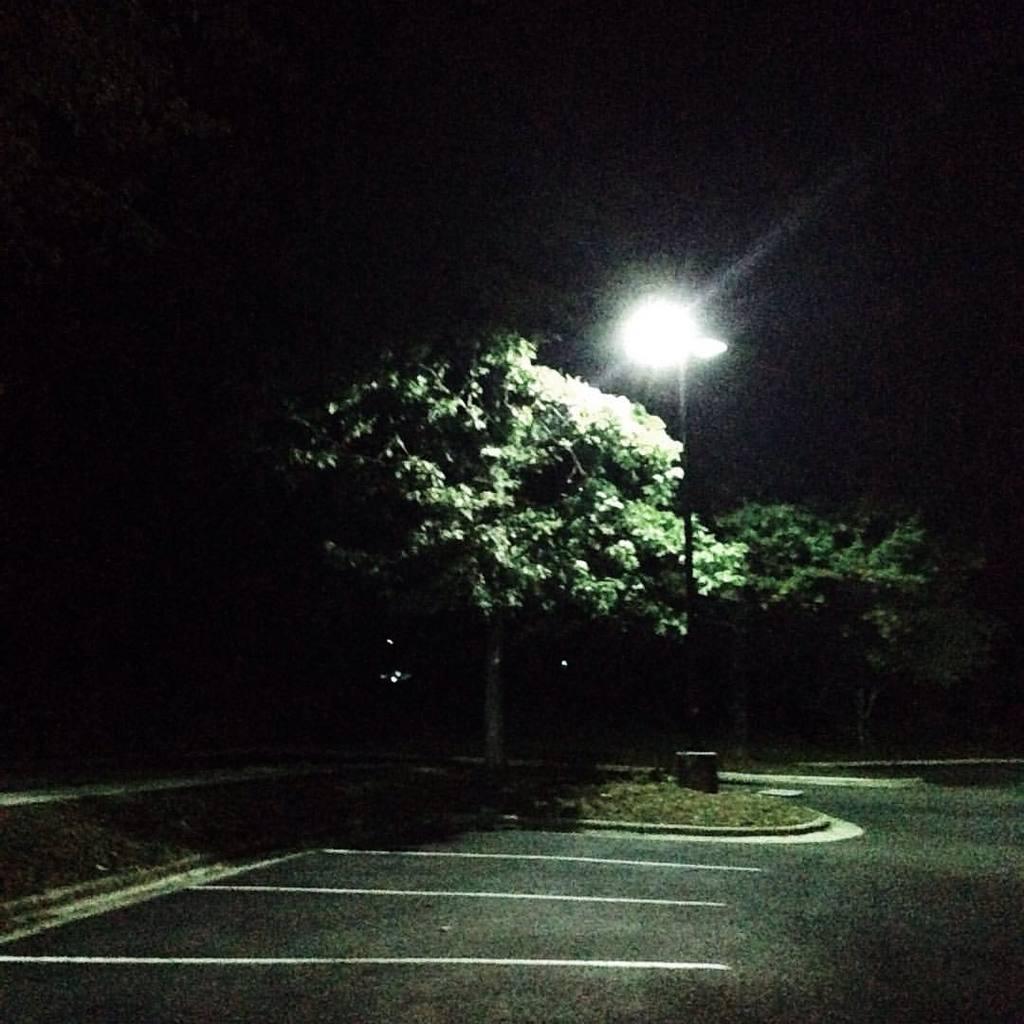Describe this image in one or two sentences. In this picture we can see the road, grass, light pole, trees and in the background it is dark. 